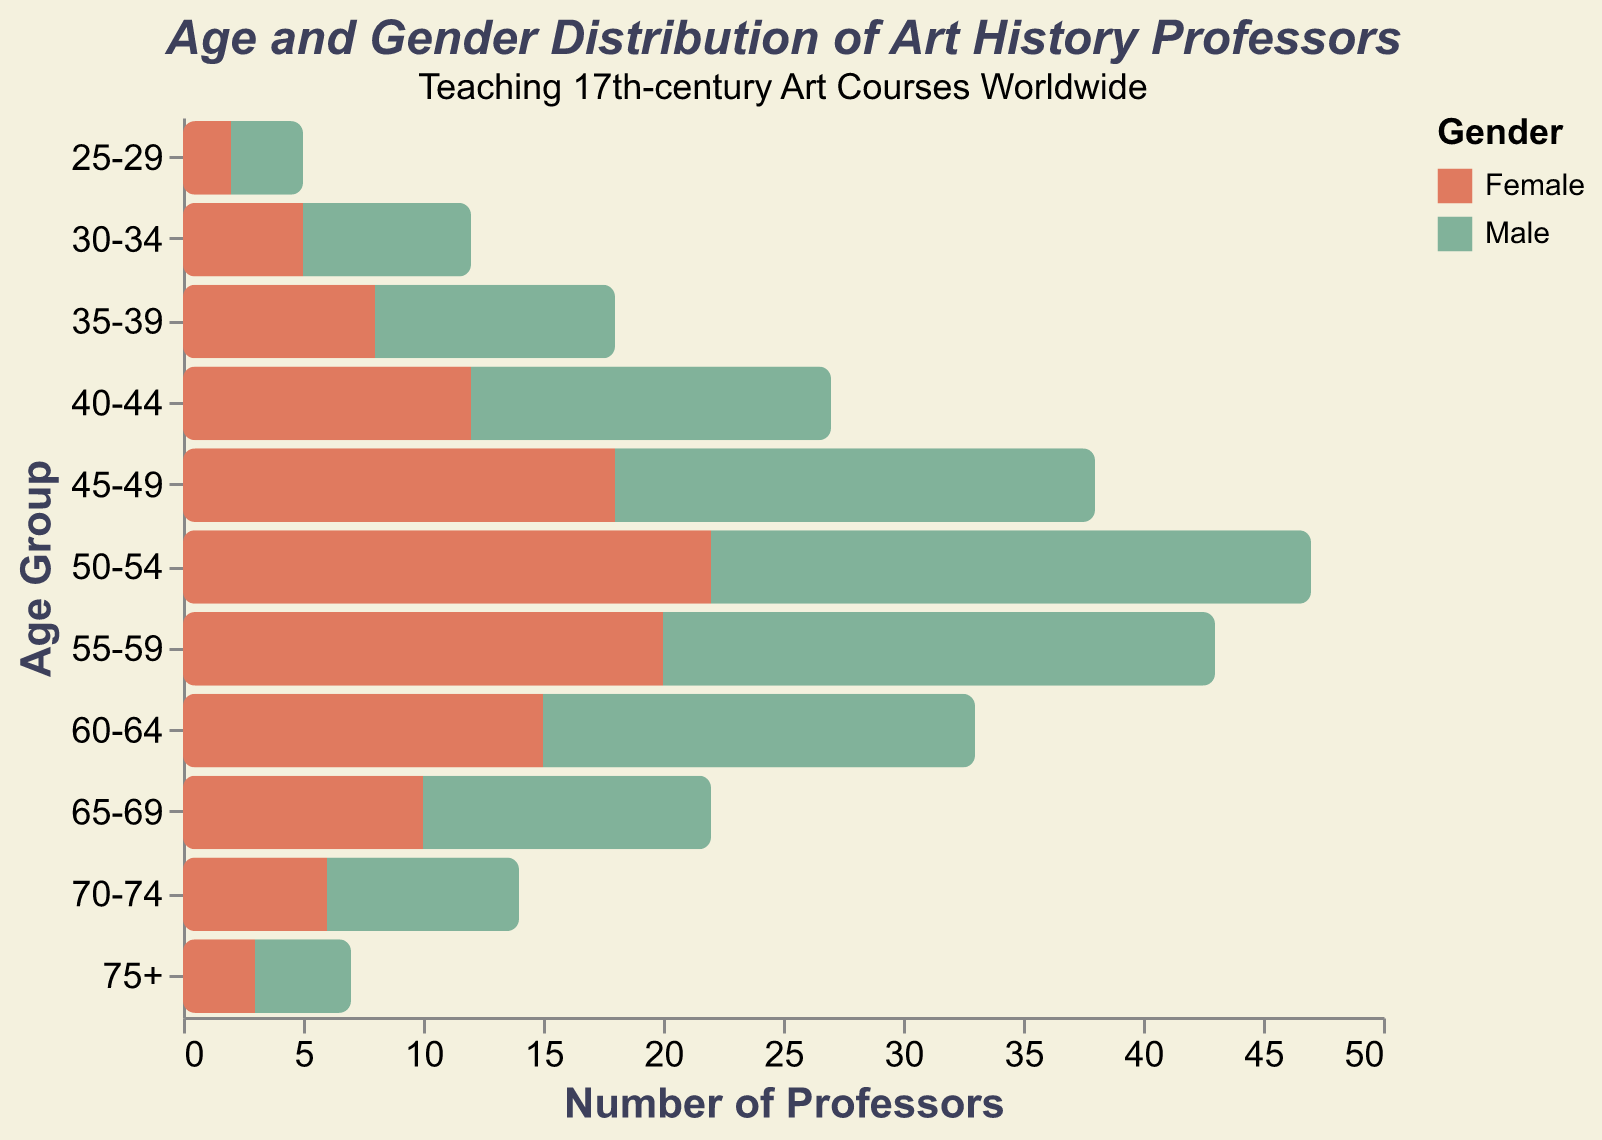What's the most represented age group for both genders combined? To find the most represented age group, sum the values for both genders in each age group and compare them. The 50-54 group has the highest total (22 females + 25 males = 47).
Answer: 50-54 How many more female professors are there in the 50-54 age group compared to males? In the 50-54 age group, there are 22 females and 25 males. The male values are negative, so the difference is 22 + 25 = 47.
Answer: 47 Which age group has the smallest difference in the number of professors between males and females? Calculate the absolute difference for each age group. The 25-29 group has the smallest difference, 1:
Answer: 25-29 In which age group are there the highest number of male professors? Identify the age group with the smallest negative value (most negative value in absolute sense) for males. The 50-54 group has -25, which is the highest in absolute numbers (25).
Answer: 50-54 Compare the number of female and male professors in the 40-44 age group. Who is more prevalent? In the 40-44 age group, females are 12, and males are 15. The male value is -15, which is higher than the 12 females, so there are more male professors.
Answer: Males What is the age group with the most balanced number of professors in terms of gender ratio? Check the age groups for the closest ratios. The balanced ratio is when the absolute difference is the smallest, which is 25-29 with a difference of 1 (2 females, 3 males).
Answer: 25-29 How does the number of male professors in the 55-59 age group compare to the number of female professors? In this group, there are 20 females and 23 males with an absolute value comparison, males are 3 more than females.
Answer: Males What is the total number of professors in the age group 65-69? Combine both genders' values for the 65-69 group: 10 (female) + 12 (male) = 22.
Answer: 22 In which age groups do females outnumber males? Compare the positive value for females and corresponding negative values for males. Females outnumber males in 25-29, 30-34, 35-39, 40-44, 45-49, 50-54, and 55-59.
Answer: 25-29, 30-34, 35-39, 40-44, 45-49, 50-54, 55-59 